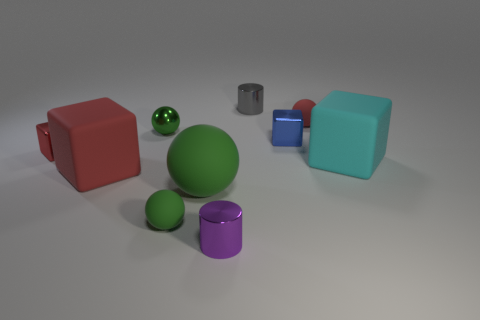Subtract all green blocks. How many green spheres are left? 3 Subtract 1 spheres. How many spheres are left? 3 Subtract all blocks. How many objects are left? 6 Add 8 big cyan cubes. How many big cyan cubes are left? 9 Add 5 red things. How many red things exist? 8 Subtract 0 cyan spheres. How many objects are left? 10 Subtract all cylinders. Subtract all gray metal balls. How many objects are left? 8 